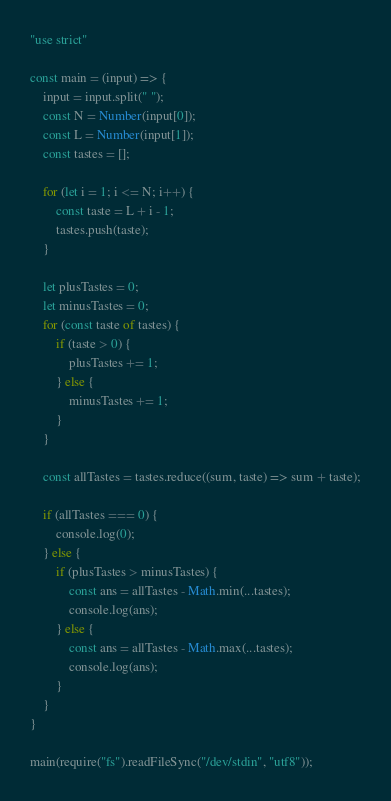<code> <loc_0><loc_0><loc_500><loc_500><_JavaScript_>"use strict"

const main = (input) => {
    input = input.split(" ");
    const N = Number(input[0]);
    const L = Number(input[1]);
    const tastes = [];

    for (let i = 1; i <= N; i++) {
        const taste = L + i - 1;
        tastes.push(taste);
    }

    let plusTastes = 0;
    let minusTastes = 0;
    for (const taste of tastes) {
        if (taste > 0) {
            plusTastes += 1;
        } else {
            minusTastes += 1;
        }
    }

    const allTastes = tastes.reduce((sum, taste) => sum + taste);

    if (allTastes === 0) {
        console.log(0);
    } else {
        if (plusTastes > minusTastes) {
            const ans = allTastes - Math.min(...tastes);
            console.log(ans);
        } else {
            const ans = allTastes - Math.max(...tastes);
            console.log(ans);
        }
    }
}

main(require("fs").readFileSync("/dev/stdin", "utf8"));</code> 